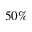Convert formula to latex. <formula><loc_0><loc_0><loc_500><loc_500>5 0 \%</formula> 